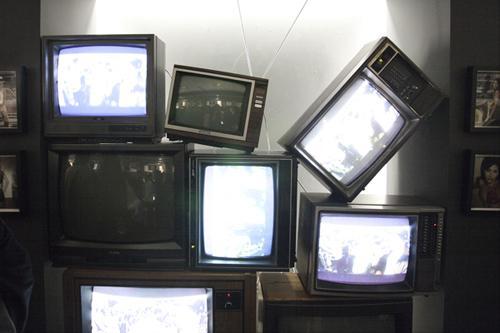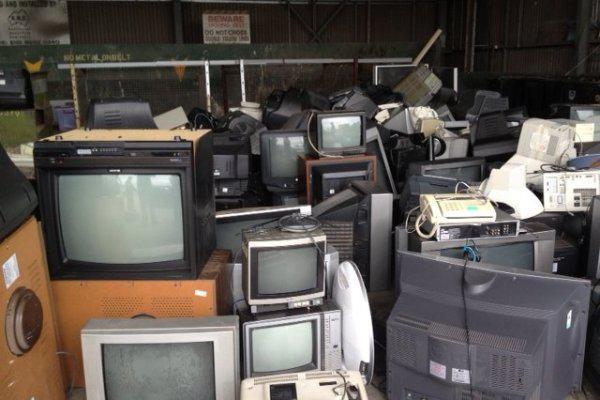The first image is the image on the left, the second image is the image on the right. Considering the images on both sides, is "At least one image shows an upward view of 'endless' stacked televisions that feature three round white knobs in a horizontal row right of the screen." valid? Answer yes or no. No. 